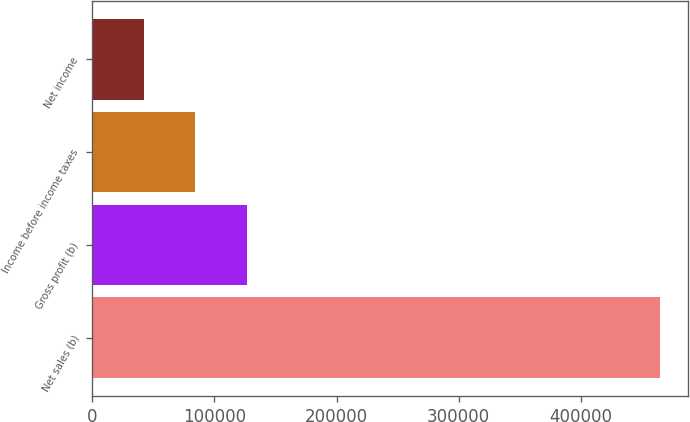<chart> <loc_0><loc_0><loc_500><loc_500><bar_chart><fcel>Net sales (b)<fcel>Gross profit (b)<fcel>Income before income taxes<fcel>Net income<nl><fcel>464755<fcel>126712<fcel>84456.4<fcel>42201<nl></chart> 